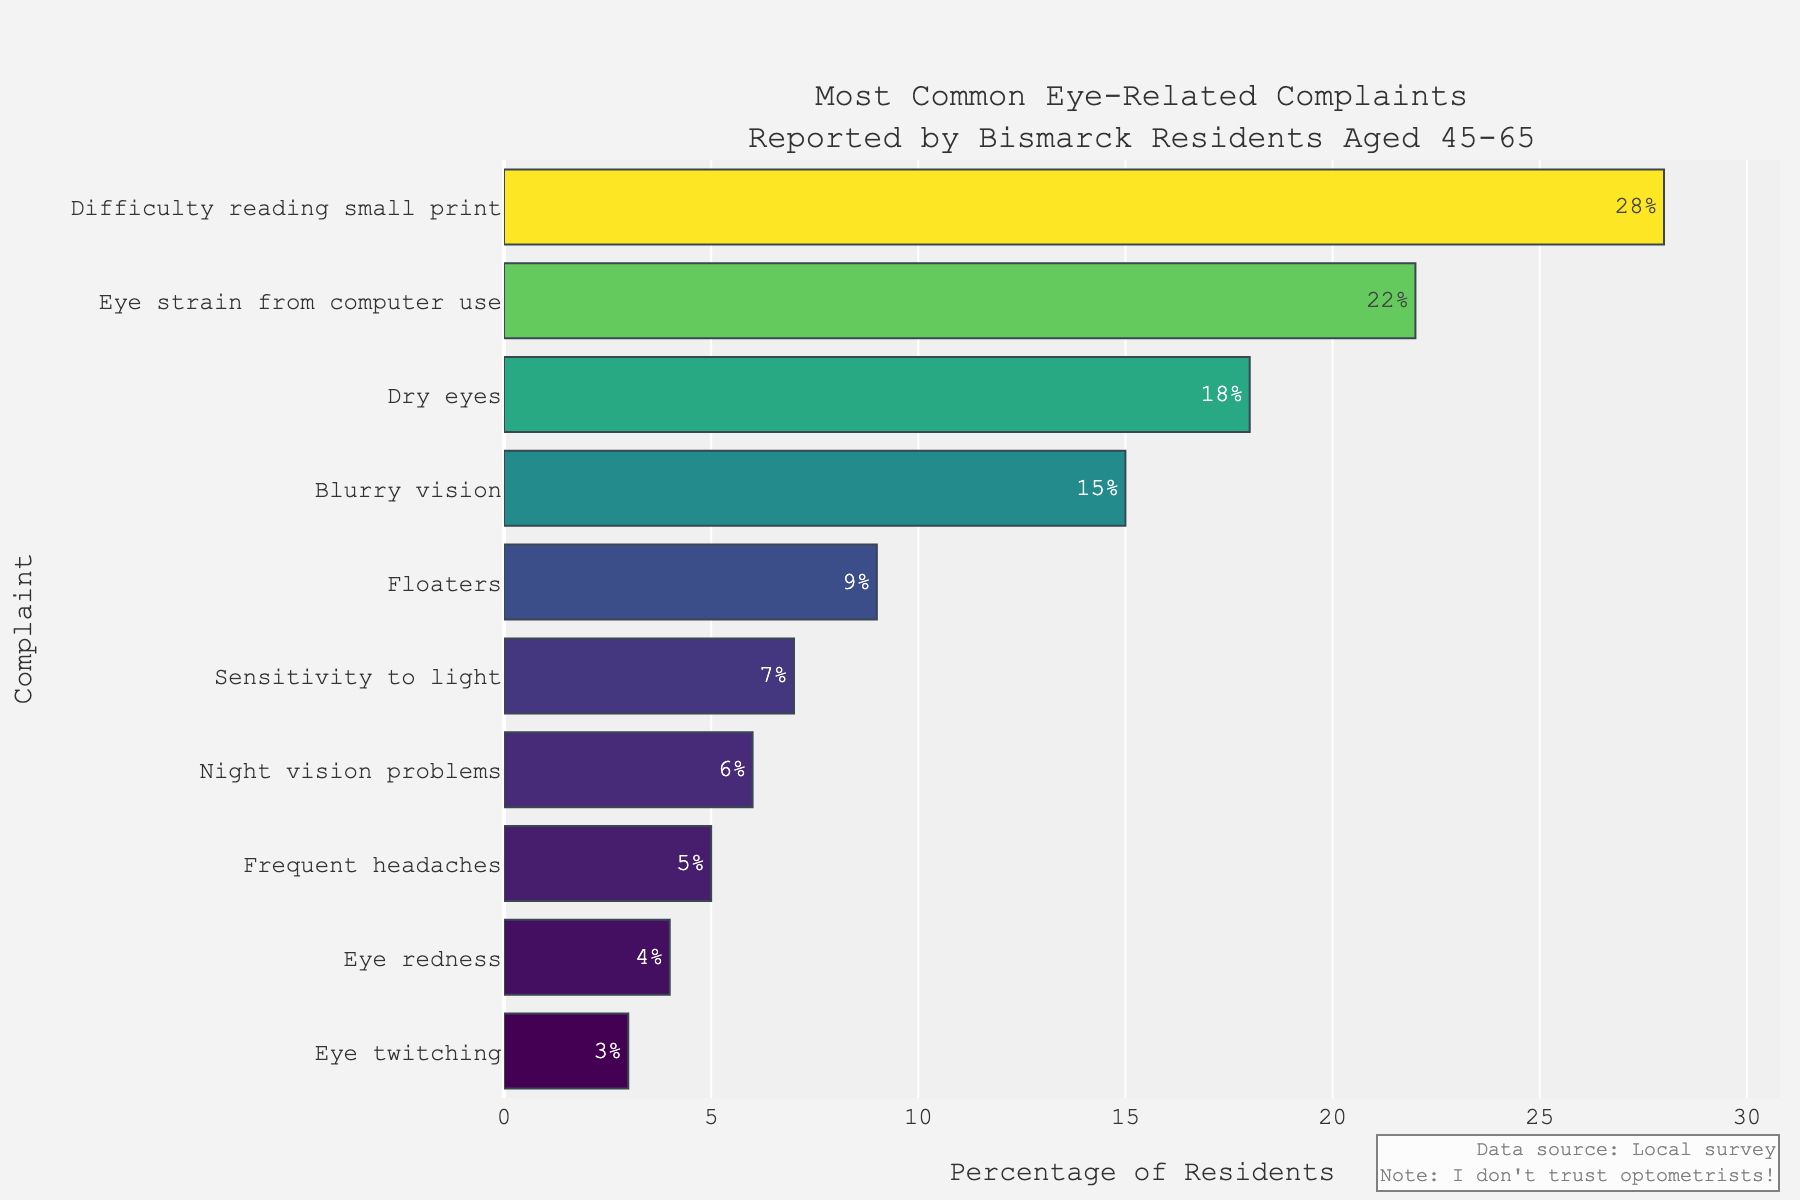What is the most common eye-related complaint reported by Bismarck residents aged 45-65? The figure shows a sorted bar chart where the complaint with the highest percentage is at the top. "Difficulty reading small print" is the topmost complaint with the highest percentage of 28%.
Answer: Difficulty reading small print How much more common is "Eye strain from computer use" compared to "Frequent headaches"? The percentage for "Eye strain from computer use" is 22% and for "Frequent headaches" is 5%. The difference is calculated as 22% - 5% = 17%.
Answer: 17% Which complaint is less common: "Blurry vision" or "Dry eyes"? By comparing their positions and percentages on the chart, "Blurry vision" has a percentage of 15%, while "Dry eyes" has a percentage of 18%. Therefore, "Blurry vision" is less common.
Answer: Blurry vision What is the combined percentage of residents who reported "Floaters" and "Sensitivity to light"? The percentages for "Floaters" and "Sensitivity to light" are 9% and 7%, respectively. Adding these gives 9% + 7% = 16%.
Answer: 16% Which complaint has the lowest reported percentage? The chart shows that "Eye twitching" is at the bottom with the lowest percentage of 3%.
Answer: Eye twitching Is "Night vision problems" reported more or less frequently than "Floaters"? The figure shows that "Night vision problems" have a percentage of 6%, while "Floaters" have a percentage of 9%. "Night vision problems" are reported less frequently.
Answer: Less What is the range of percentages observed in the complaints? The highest percentage is "Difficulty reading small print" with 28% and the lowest is "Eye twitching" with 3%. The range is calculated as 28% - 3% = 25%.
Answer: 25% Which complaints fall below the 10% mark? By examining the chart, "Floaters" (9%), "Sensitivity to light" (7%), "Night vision problems" (6%), "Frequent headaches" (5%), "Eye redness" (4%), and "Eye twitching" (3%) all fall below the 10% mark.
Answer: Floaters, Sensitivity to light, Night vision problems, Frequent headaches, Eye redness, Eye twitching Which complaints have a reported percentage between 5% and 20%? By referring to the chart, the complaints in this range are "Dry eyes" (18%), "Blurry vision" (15%), "Floaters" (9%), "Sensitivity to light" (7%), and "Night vision problems" (6%).
Answer: Dry eyes, Blurry vision, Floaters, Sensitivity to light, Night vision problems What is the average percentage of the top three most common complaints? The top three complaints are "Difficulty reading small print" (28%), "Eye strain from computer use" (22%), and "Dry eyes" (18%). Adding them up: 28% + 22% + 18% = 68%. The average is 68% / 3 = 22.67%.
Answer: 22.67% 